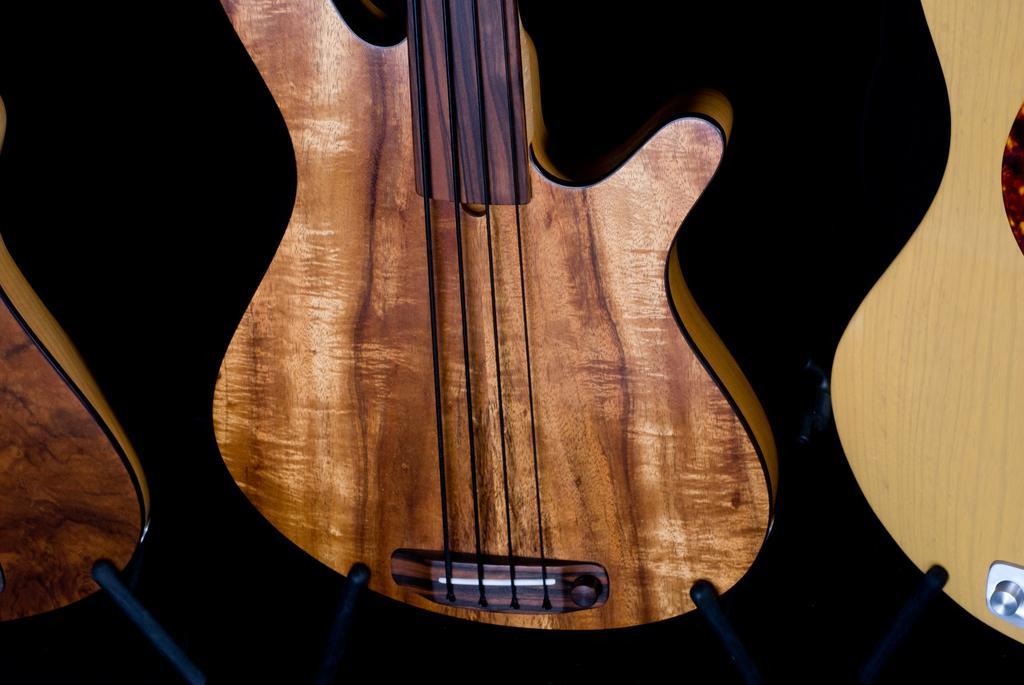In one or two sentences, can you explain what this image depicts? This picture shows a guitar on the table 